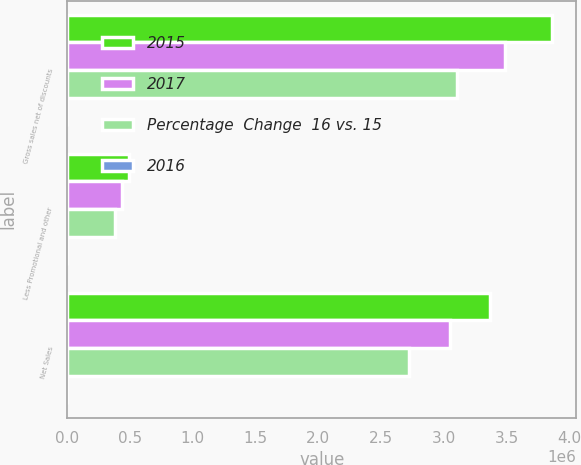Convert chart. <chart><loc_0><loc_0><loc_500><loc_500><stacked_bar_chart><ecel><fcel>Gross sales net of discounts<fcel>Less Promotional and other<fcel>Net Sales<nl><fcel>2015<fcel>3.86137e+06<fcel>492323<fcel>3.36904e+06<nl><fcel>2017<fcel>3.48546e+06<fcel>436070<fcel>3.04939e+06<nl><fcel>Percentage  Change  16 vs. 15<fcel>3.10566e+06<fcel>383101<fcel>2.72256e+06<nl><fcel>2016<fcel>10.8<fcel>12.9<fcel>10.5<nl></chart> 